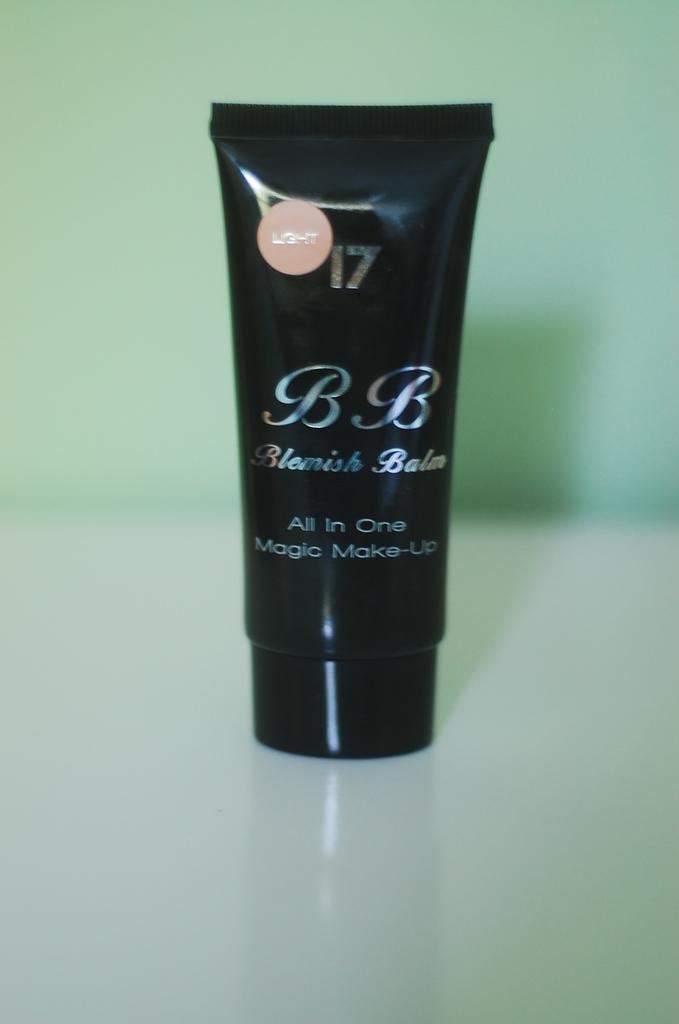<image>
Create a compact narrative representing the image presented. A tube of light shaded Blemish Balm stands on a counter. 